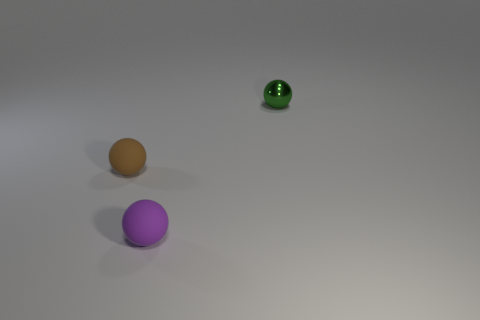Subtract all tiny brown balls. How many balls are left? 2 Add 2 green shiny blocks. How many objects exist? 5 Subtract all yellow balls. Subtract all blue blocks. How many balls are left? 3 Add 3 small brown balls. How many small brown balls are left? 4 Add 2 purple balls. How many purple balls exist? 3 Subtract 0 purple blocks. How many objects are left? 3 Subtract all small yellow matte cylinders. Subtract all tiny balls. How many objects are left? 0 